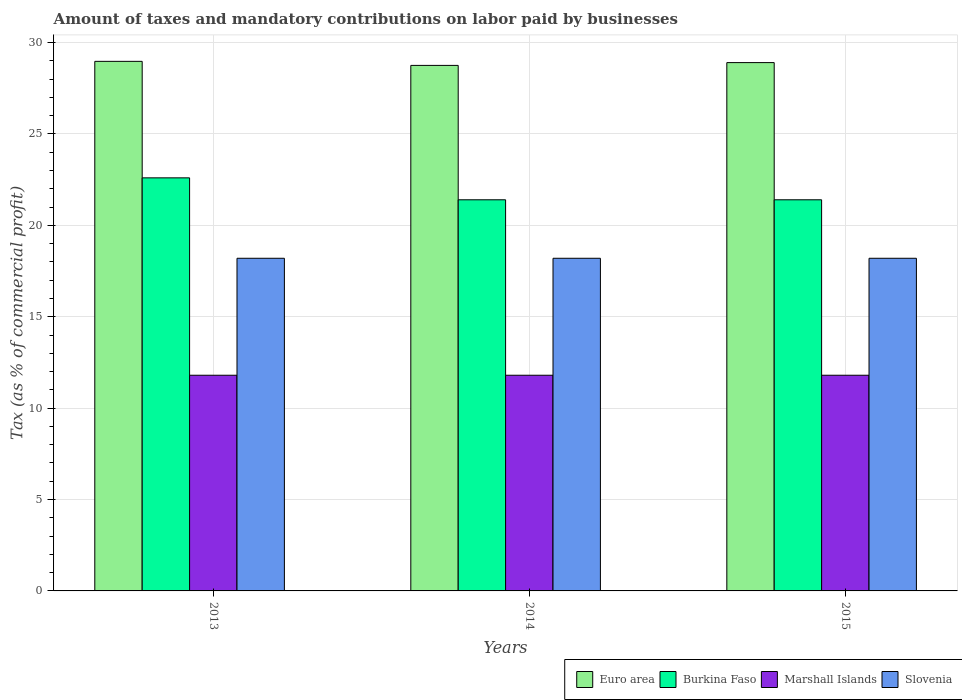Are the number of bars per tick equal to the number of legend labels?
Your answer should be very brief. Yes. How many bars are there on the 2nd tick from the right?
Provide a succinct answer. 4. What is the label of the 3rd group of bars from the left?
Your answer should be very brief. 2015. In how many cases, is the number of bars for a given year not equal to the number of legend labels?
Keep it short and to the point. 0. Across all years, what is the maximum percentage of taxes paid by businesses in Slovenia?
Your answer should be very brief. 18.2. Across all years, what is the minimum percentage of taxes paid by businesses in Euro area?
Make the answer very short. 28.75. In which year was the percentage of taxes paid by businesses in Burkina Faso maximum?
Offer a terse response. 2013. In which year was the percentage of taxes paid by businesses in Euro area minimum?
Provide a succinct answer. 2014. What is the total percentage of taxes paid by businesses in Slovenia in the graph?
Your answer should be very brief. 54.6. What is the difference between the percentage of taxes paid by businesses in Slovenia in 2013 and that in 2015?
Offer a very short reply. 0. What is the difference between the percentage of taxes paid by businesses in Euro area in 2014 and the percentage of taxes paid by businesses in Burkina Faso in 2013?
Offer a very short reply. 6.15. What is the average percentage of taxes paid by businesses in Slovenia per year?
Provide a succinct answer. 18.2. In the year 2013, what is the difference between the percentage of taxes paid by businesses in Slovenia and percentage of taxes paid by businesses in Burkina Faso?
Give a very brief answer. -4.4. In how many years, is the percentage of taxes paid by businesses in Euro area greater than 17 %?
Your answer should be very brief. 3. What is the ratio of the percentage of taxes paid by businesses in Marshall Islands in 2014 to that in 2015?
Ensure brevity in your answer.  1. Is the percentage of taxes paid by businesses in Burkina Faso in 2013 less than that in 2014?
Provide a succinct answer. No. Is the difference between the percentage of taxes paid by businesses in Slovenia in 2014 and 2015 greater than the difference between the percentage of taxes paid by businesses in Burkina Faso in 2014 and 2015?
Make the answer very short. No. What is the difference between the highest and the lowest percentage of taxes paid by businesses in Euro area?
Provide a succinct answer. 0.22. In how many years, is the percentage of taxes paid by businesses in Marshall Islands greater than the average percentage of taxes paid by businesses in Marshall Islands taken over all years?
Offer a terse response. 0. Is the sum of the percentage of taxes paid by businesses in Slovenia in 2014 and 2015 greater than the maximum percentage of taxes paid by businesses in Burkina Faso across all years?
Make the answer very short. Yes. What does the 1st bar from the left in 2013 represents?
Give a very brief answer. Euro area. What does the 1st bar from the right in 2015 represents?
Your answer should be very brief. Slovenia. Are all the bars in the graph horizontal?
Give a very brief answer. No. How many years are there in the graph?
Keep it short and to the point. 3. Are the values on the major ticks of Y-axis written in scientific E-notation?
Keep it short and to the point. No. Where does the legend appear in the graph?
Ensure brevity in your answer.  Bottom right. How are the legend labels stacked?
Provide a short and direct response. Horizontal. What is the title of the graph?
Your response must be concise. Amount of taxes and mandatory contributions on labor paid by businesses. What is the label or title of the X-axis?
Offer a very short reply. Years. What is the label or title of the Y-axis?
Make the answer very short. Tax (as % of commercial profit). What is the Tax (as % of commercial profit) of Euro area in 2013?
Provide a succinct answer. 28.97. What is the Tax (as % of commercial profit) of Burkina Faso in 2013?
Give a very brief answer. 22.6. What is the Tax (as % of commercial profit) in Slovenia in 2013?
Offer a very short reply. 18.2. What is the Tax (as % of commercial profit) of Euro area in 2014?
Make the answer very short. 28.75. What is the Tax (as % of commercial profit) of Burkina Faso in 2014?
Ensure brevity in your answer.  21.4. What is the Tax (as % of commercial profit) in Slovenia in 2014?
Your answer should be compact. 18.2. What is the Tax (as % of commercial profit) of Euro area in 2015?
Provide a short and direct response. 28.91. What is the Tax (as % of commercial profit) of Burkina Faso in 2015?
Give a very brief answer. 21.4. What is the Tax (as % of commercial profit) of Marshall Islands in 2015?
Provide a short and direct response. 11.8. What is the Tax (as % of commercial profit) in Slovenia in 2015?
Offer a very short reply. 18.2. Across all years, what is the maximum Tax (as % of commercial profit) in Euro area?
Ensure brevity in your answer.  28.97. Across all years, what is the maximum Tax (as % of commercial profit) of Burkina Faso?
Keep it short and to the point. 22.6. Across all years, what is the maximum Tax (as % of commercial profit) in Marshall Islands?
Your answer should be compact. 11.8. Across all years, what is the maximum Tax (as % of commercial profit) in Slovenia?
Keep it short and to the point. 18.2. Across all years, what is the minimum Tax (as % of commercial profit) in Euro area?
Offer a very short reply. 28.75. Across all years, what is the minimum Tax (as % of commercial profit) in Burkina Faso?
Your response must be concise. 21.4. Across all years, what is the minimum Tax (as % of commercial profit) in Slovenia?
Keep it short and to the point. 18.2. What is the total Tax (as % of commercial profit) in Euro area in the graph?
Give a very brief answer. 86.63. What is the total Tax (as % of commercial profit) of Burkina Faso in the graph?
Offer a very short reply. 65.4. What is the total Tax (as % of commercial profit) of Marshall Islands in the graph?
Your response must be concise. 35.4. What is the total Tax (as % of commercial profit) in Slovenia in the graph?
Your response must be concise. 54.6. What is the difference between the Tax (as % of commercial profit) of Euro area in 2013 and that in 2014?
Offer a very short reply. 0.22. What is the difference between the Tax (as % of commercial profit) in Burkina Faso in 2013 and that in 2014?
Your response must be concise. 1.2. What is the difference between the Tax (as % of commercial profit) in Marshall Islands in 2013 and that in 2014?
Keep it short and to the point. 0. What is the difference between the Tax (as % of commercial profit) of Slovenia in 2013 and that in 2014?
Your response must be concise. 0. What is the difference between the Tax (as % of commercial profit) of Euro area in 2013 and that in 2015?
Provide a short and direct response. 0.07. What is the difference between the Tax (as % of commercial profit) in Burkina Faso in 2013 and that in 2015?
Ensure brevity in your answer.  1.2. What is the difference between the Tax (as % of commercial profit) in Marshall Islands in 2013 and that in 2015?
Offer a terse response. 0. What is the difference between the Tax (as % of commercial profit) of Euro area in 2014 and that in 2015?
Provide a short and direct response. -0.15. What is the difference between the Tax (as % of commercial profit) of Marshall Islands in 2014 and that in 2015?
Provide a short and direct response. 0. What is the difference between the Tax (as % of commercial profit) of Euro area in 2013 and the Tax (as % of commercial profit) of Burkina Faso in 2014?
Your answer should be very brief. 7.57. What is the difference between the Tax (as % of commercial profit) in Euro area in 2013 and the Tax (as % of commercial profit) in Marshall Islands in 2014?
Offer a terse response. 17.17. What is the difference between the Tax (as % of commercial profit) of Euro area in 2013 and the Tax (as % of commercial profit) of Slovenia in 2014?
Provide a succinct answer. 10.77. What is the difference between the Tax (as % of commercial profit) of Burkina Faso in 2013 and the Tax (as % of commercial profit) of Slovenia in 2014?
Keep it short and to the point. 4.4. What is the difference between the Tax (as % of commercial profit) of Euro area in 2013 and the Tax (as % of commercial profit) of Burkina Faso in 2015?
Your response must be concise. 7.57. What is the difference between the Tax (as % of commercial profit) of Euro area in 2013 and the Tax (as % of commercial profit) of Marshall Islands in 2015?
Your response must be concise. 17.17. What is the difference between the Tax (as % of commercial profit) in Euro area in 2013 and the Tax (as % of commercial profit) in Slovenia in 2015?
Provide a short and direct response. 10.77. What is the difference between the Tax (as % of commercial profit) of Burkina Faso in 2013 and the Tax (as % of commercial profit) of Marshall Islands in 2015?
Ensure brevity in your answer.  10.8. What is the difference between the Tax (as % of commercial profit) of Euro area in 2014 and the Tax (as % of commercial profit) of Burkina Faso in 2015?
Give a very brief answer. 7.35. What is the difference between the Tax (as % of commercial profit) in Euro area in 2014 and the Tax (as % of commercial profit) in Marshall Islands in 2015?
Provide a succinct answer. 16.95. What is the difference between the Tax (as % of commercial profit) in Euro area in 2014 and the Tax (as % of commercial profit) in Slovenia in 2015?
Offer a terse response. 10.55. What is the average Tax (as % of commercial profit) of Euro area per year?
Ensure brevity in your answer.  28.88. What is the average Tax (as % of commercial profit) of Burkina Faso per year?
Your answer should be compact. 21.8. What is the average Tax (as % of commercial profit) of Marshall Islands per year?
Your response must be concise. 11.8. In the year 2013, what is the difference between the Tax (as % of commercial profit) in Euro area and Tax (as % of commercial profit) in Burkina Faso?
Make the answer very short. 6.37. In the year 2013, what is the difference between the Tax (as % of commercial profit) of Euro area and Tax (as % of commercial profit) of Marshall Islands?
Provide a succinct answer. 17.17. In the year 2013, what is the difference between the Tax (as % of commercial profit) of Euro area and Tax (as % of commercial profit) of Slovenia?
Provide a short and direct response. 10.77. In the year 2013, what is the difference between the Tax (as % of commercial profit) of Burkina Faso and Tax (as % of commercial profit) of Slovenia?
Offer a terse response. 4.4. In the year 2014, what is the difference between the Tax (as % of commercial profit) of Euro area and Tax (as % of commercial profit) of Burkina Faso?
Ensure brevity in your answer.  7.35. In the year 2014, what is the difference between the Tax (as % of commercial profit) in Euro area and Tax (as % of commercial profit) in Marshall Islands?
Provide a succinct answer. 16.95. In the year 2014, what is the difference between the Tax (as % of commercial profit) of Euro area and Tax (as % of commercial profit) of Slovenia?
Ensure brevity in your answer.  10.55. In the year 2014, what is the difference between the Tax (as % of commercial profit) in Burkina Faso and Tax (as % of commercial profit) in Marshall Islands?
Give a very brief answer. 9.6. In the year 2015, what is the difference between the Tax (as % of commercial profit) in Euro area and Tax (as % of commercial profit) in Burkina Faso?
Provide a succinct answer. 7.51. In the year 2015, what is the difference between the Tax (as % of commercial profit) of Euro area and Tax (as % of commercial profit) of Marshall Islands?
Make the answer very short. 17.11. In the year 2015, what is the difference between the Tax (as % of commercial profit) in Euro area and Tax (as % of commercial profit) in Slovenia?
Provide a succinct answer. 10.71. In the year 2015, what is the difference between the Tax (as % of commercial profit) of Burkina Faso and Tax (as % of commercial profit) of Marshall Islands?
Offer a very short reply. 9.6. In the year 2015, what is the difference between the Tax (as % of commercial profit) of Burkina Faso and Tax (as % of commercial profit) of Slovenia?
Make the answer very short. 3.2. In the year 2015, what is the difference between the Tax (as % of commercial profit) of Marshall Islands and Tax (as % of commercial profit) of Slovenia?
Offer a terse response. -6.4. What is the ratio of the Tax (as % of commercial profit) of Euro area in 2013 to that in 2014?
Provide a short and direct response. 1.01. What is the ratio of the Tax (as % of commercial profit) of Burkina Faso in 2013 to that in 2014?
Keep it short and to the point. 1.06. What is the ratio of the Tax (as % of commercial profit) of Burkina Faso in 2013 to that in 2015?
Ensure brevity in your answer.  1.06. What is the ratio of the Tax (as % of commercial profit) in Slovenia in 2013 to that in 2015?
Offer a terse response. 1. What is the ratio of the Tax (as % of commercial profit) in Euro area in 2014 to that in 2015?
Your answer should be compact. 0.99. What is the ratio of the Tax (as % of commercial profit) in Burkina Faso in 2014 to that in 2015?
Ensure brevity in your answer.  1. What is the ratio of the Tax (as % of commercial profit) in Slovenia in 2014 to that in 2015?
Offer a very short reply. 1. What is the difference between the highest and the second highest Tax (as % of commercial profit) of Euro area?
Provide a short and direct response. 0.07. What is the difference between the highest and the second highest Tax (as % of commercial profit) of Burkina Faso?
Your response must be concise. 1.2. What is the difference between the highest and the second highest Tax (as % of commercial profit) in Marshall Islands?
Your response must be concise. 0. What is the difference between the highest and the lowest Tax (as % of commercial profit) in Euro area?
Your answer should be compact. 0.22. What is the difference between the highest and the lowest Tax (as % of commercial profit) in Burkina Faso?
Keep it short and to the point. 1.2. What is the difference between the highest and the lowest Tax (as % of commercial profit) in Marshall Islands?
Your response must be concise. 0. What is the difference between the highest and the lowest Tax (as % of commercial profit) in Slovenia?
Your answer should be very brief. 0. 